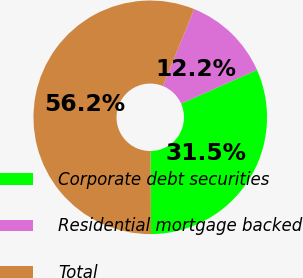<chart> <loc_0><loc_0><loc_500><loc_500><pie_chart><fcel>Corporate debt securities<fcel>Residential mortgage backed<fcel>Total<nl><fcel>31.54%<fcel>12.22%<fcel>56.24%<nl></chart> 